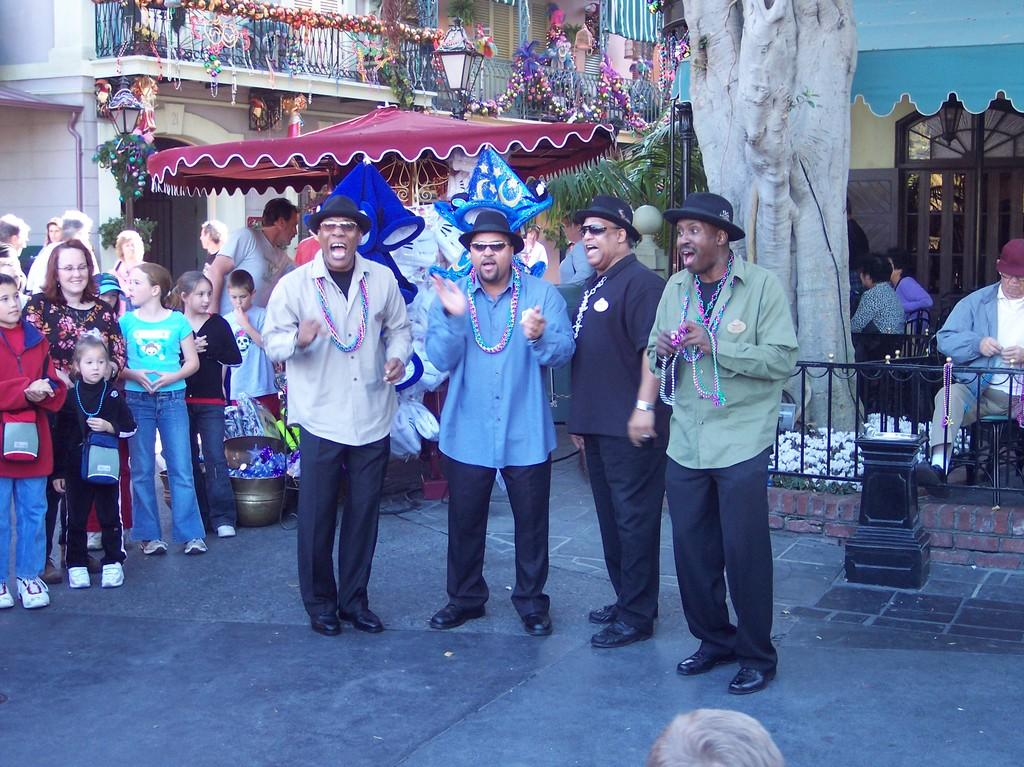What are the people in the image doing? The people in the image are standing on a pavement. What can be seen in the background of the image? There are trees, tents, and buildings in the background of the image. What type of appliance is being used to promote growth in the image? There is no appliance present in the image, and no growth is being promoted. 